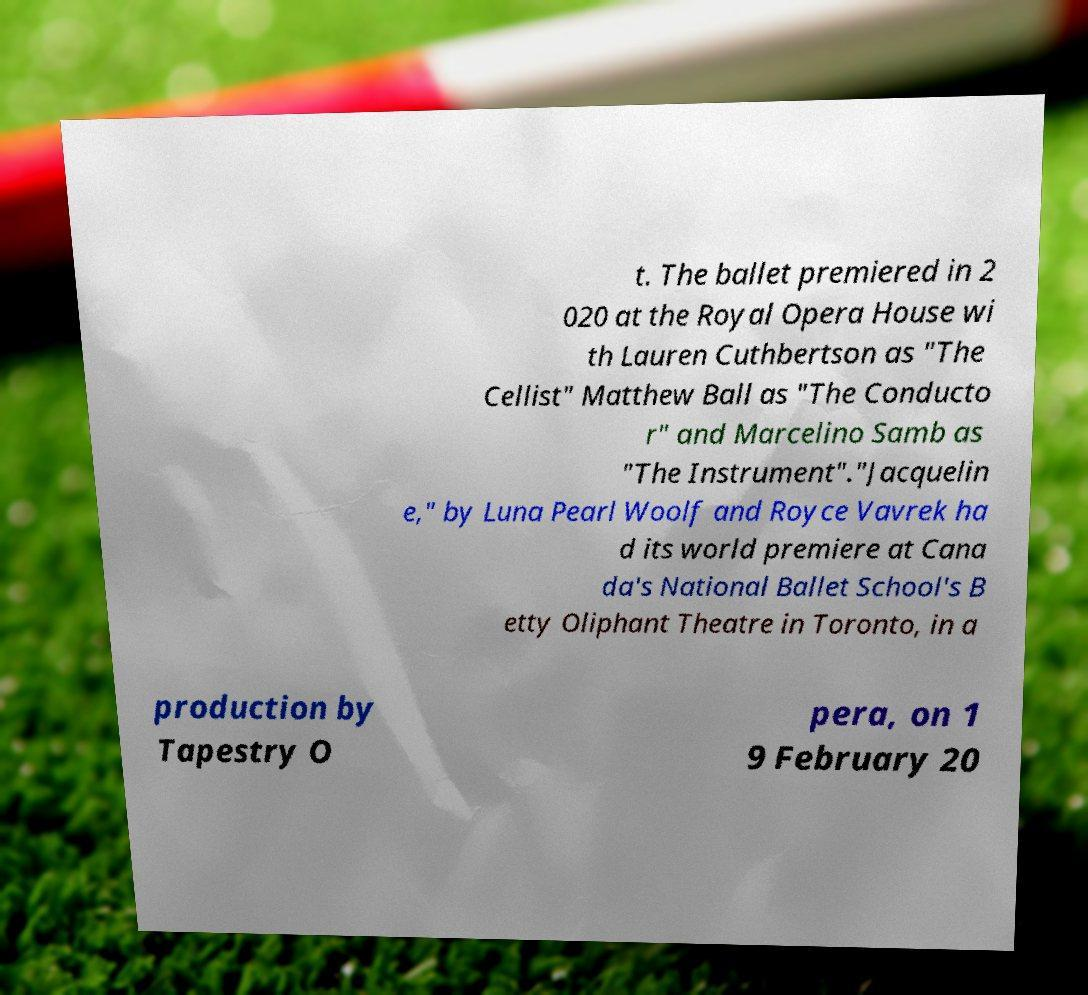What messages or text are displayed in this image? I need them in a readable, typed format. t. The ballet premiered in 2 020 at the Royal Opera House wi th Lauren Cuthbertson as "The Cellist" Matthew Ball as "The Conducto r" and Marcelino Samb as "The Instrument"."Jacquelin e," by Luna Pearl Woolf and Royce Vavrek ha d its world premiere at Cana da's National Ballet School's B etty Oliphant Theatre in Toronto, in a production by Tapestry O pera, on 1 9 February 20 